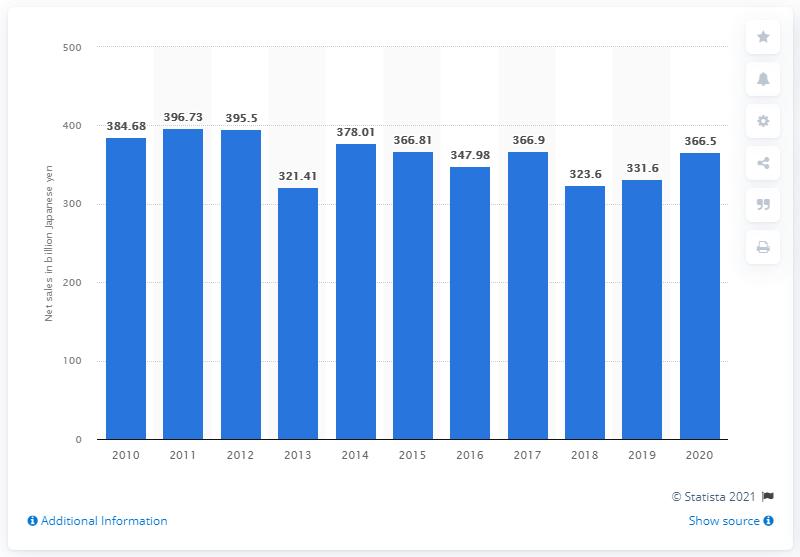Specify some key components in this picture. In the last fiscal year, Sega Sammy's net sales revenue in yen was 366.5 billion yen. 